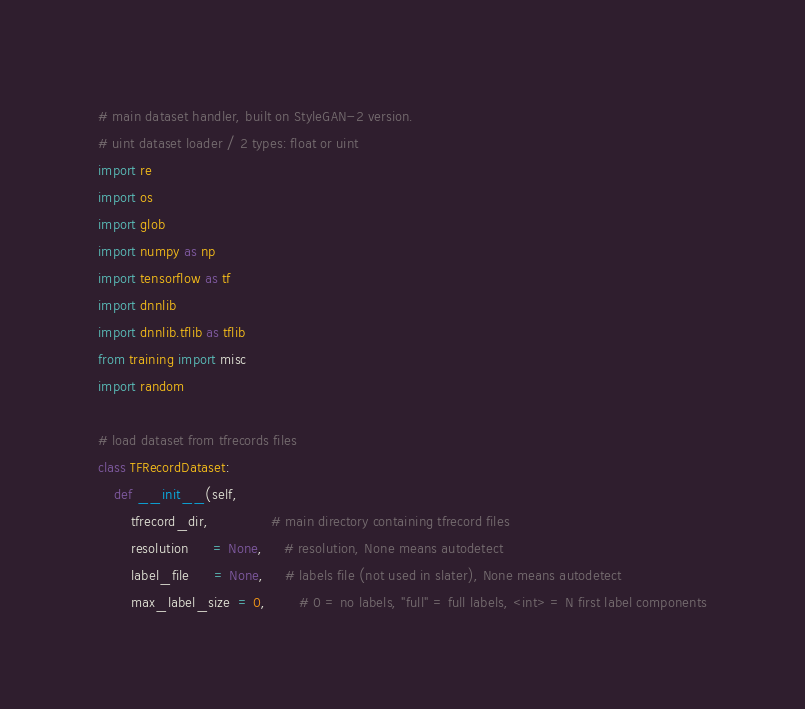Convert code to text. <code><loc_0><loc_0><loc_500><loc_500><_Python_># main dataset handler, built on StyleGAN-2 version.
# uint dataset loader / 2 types: float or uint
import re
import os
import glob
import numpy as np
import tensorflow as tf
import dnnlib
import dnnlib.tflib as tflib
from training import misc
import random

# load dataset from tfrecords files
class TFRecordDataset:
    def __init__(self,
        tfrecord_dir,               # main directory containing tfrecord files
        resolution      = None,     # resolution, None means autodetect
        label_file      = None,     # labels file (not used in slater), None means autodetect
        max_label_size  = 0,        # 0 = no labels, "full" = full labels, <int> = N first label components</code> 